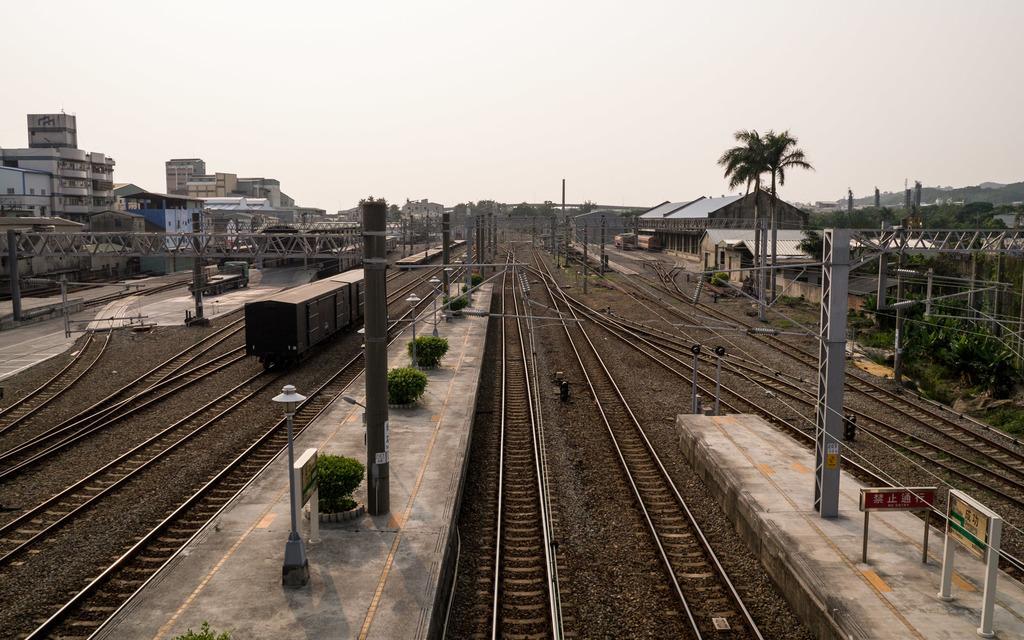In one or two sentences, can you explain what this image depicts? In this image there are so many tracks and also there is a train on the track, beside that there is a platform, trees, buildings and poles. 